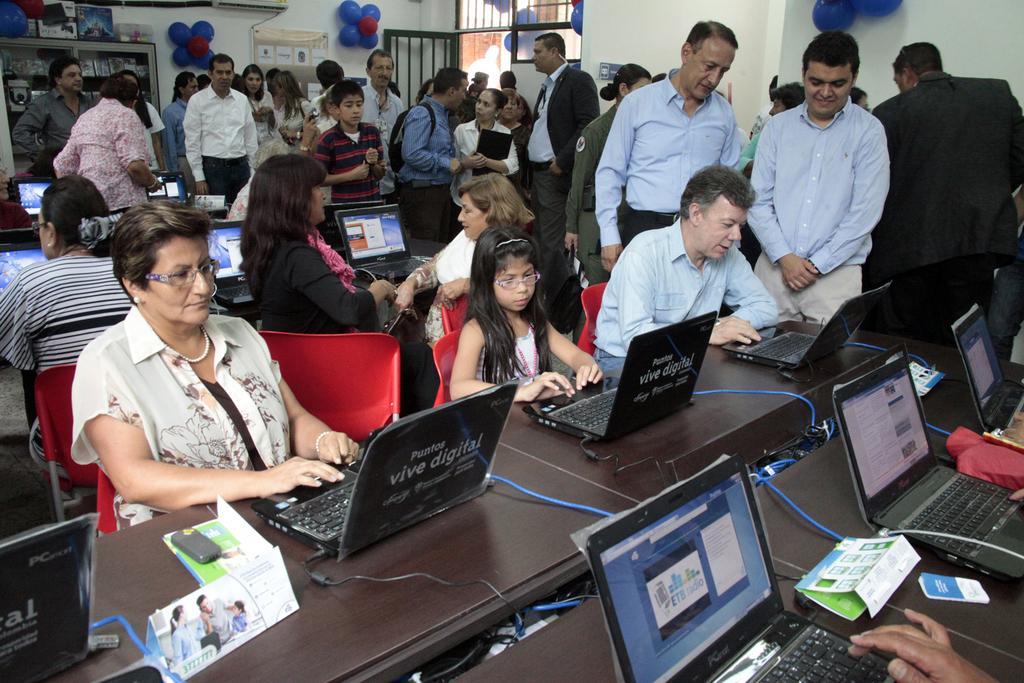How would you summarize this image in a sentence or two? This picture is taken inside the room. In this image, we can see a group of people sitting on the chair in front of the table, at that table, we can see some laptops, electrical wires, mobile, board. In the background, we can see a group of people standing, balloons, wall and a shelf, photo frame, door. 